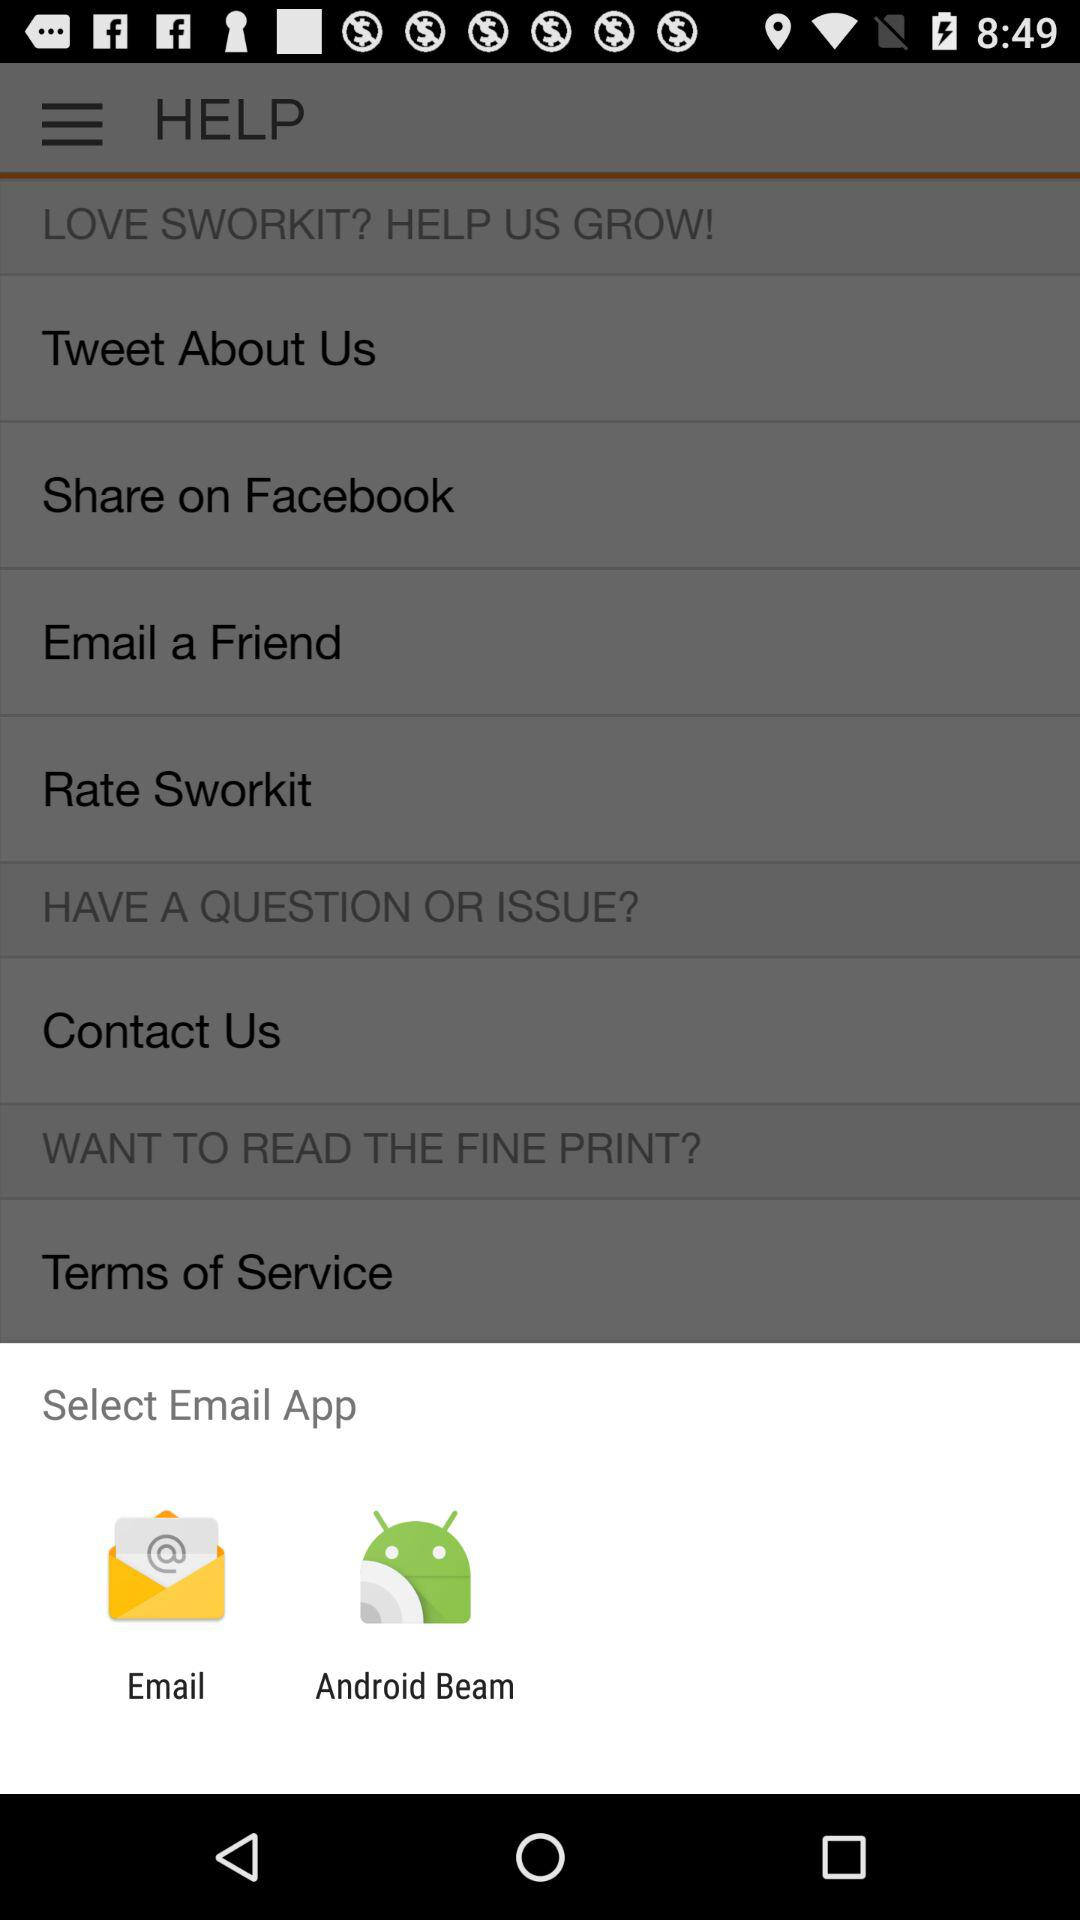What are the given email applications? The given email applications are "Email" and "Android Beam". 